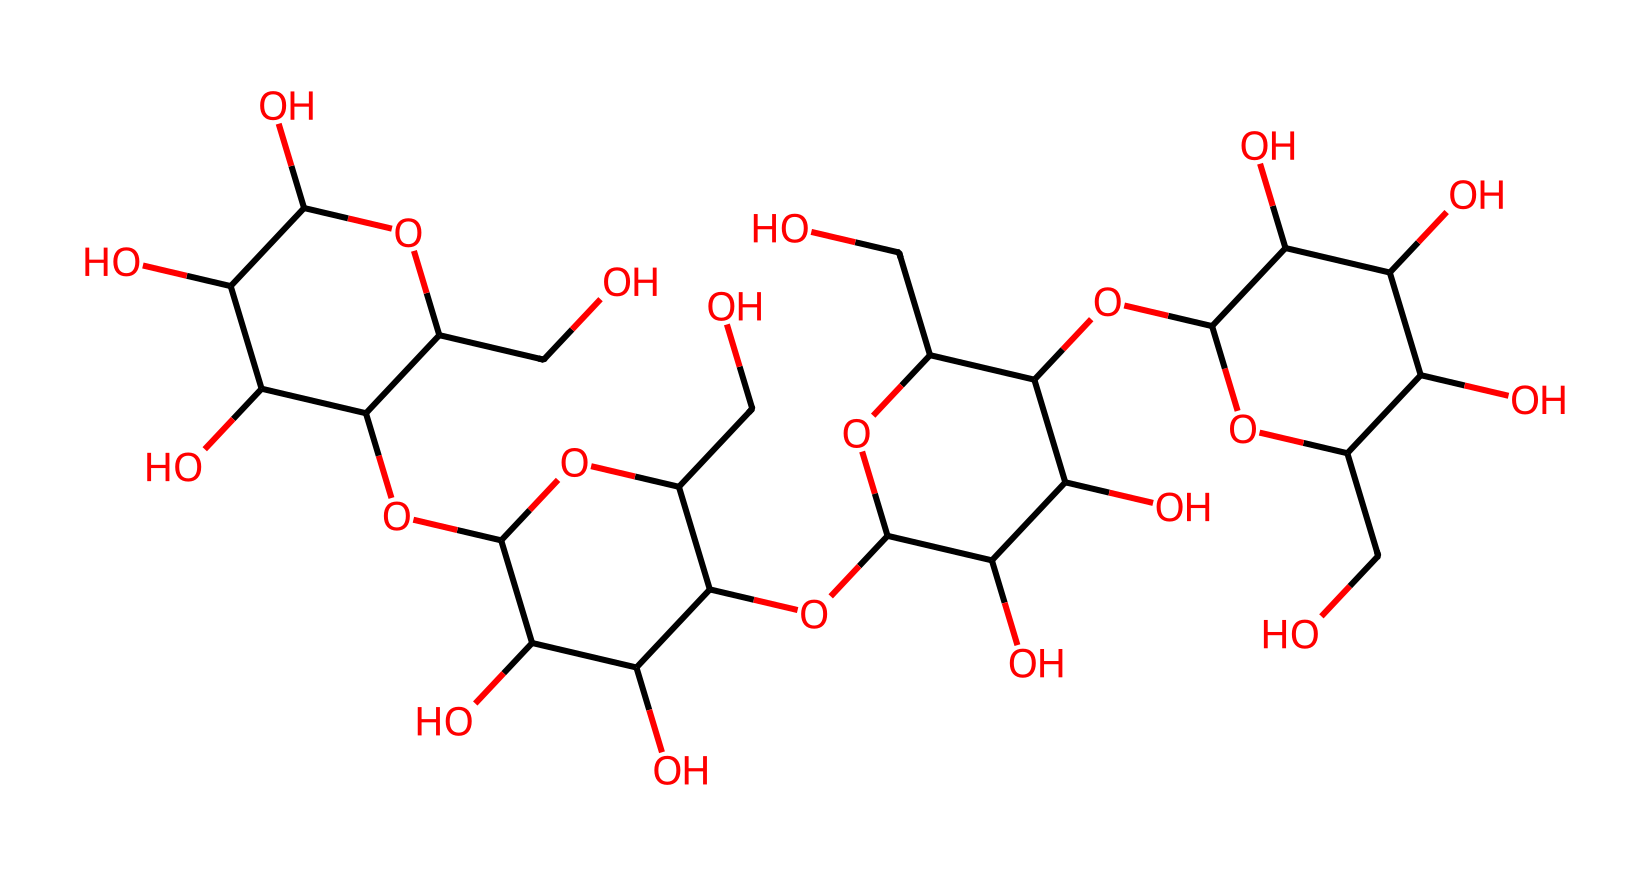How many carbon atoms are in the structure? The structure can be analyzed by counting the number of carbon atoms represented by "C" in the SMILES notation. There are 6 distinct carbon structures, repeated several times in the polysaccharide. In total, there are 6 carbon atoms in the structure.
Answer: 6 What is the primary type of linkage in this cellulose structure? The primary linkage in cellulose is β(1→4) glycosidic bonds, which can be inferred from the presence of repeating units and the structure shown in the cellulose formula. This specific linkage type is fundamental to the cellulose fiber structure.
Answer: β(1→4) glycosidic bonds How many hydroxyl (OH) groups are present in this cellulose structure? Hydroxyl groups are indicated by "O" directly connected to "C." By examining the SMILES notation, we can spot 8 instances where this connection occurs, indicating the presence of hydroxyl groups in this cellulose structure.
Answer: 8 What structural feature makes cellulose fibers strong? The long chains of glucose units and their ability to form intermolecular hydrogen bonds are responsible for the strength of cellulose fibers. This is a key characteristic seen within the SMILES, where the arrangement allows for significant bonding potential.
Answer: hydrogen bonds Is this structure soluble in water? Due to the high number of hydroxyl groups present in cellulose, which can form hydrogen bonds with water, this substance is typically not soluble despite its affinity for moisture. Therefore, we conclude that it has low water solubility overall.
Answer: low What type of polysaccharide is this cellulose structure a part of? The structure fits the criteria for a homopolysaccharide, which is indicated by the repeating units of glucose molecules connected by glycosidic bonds in the SMILES notation.
Answer: homopolysaccharide 